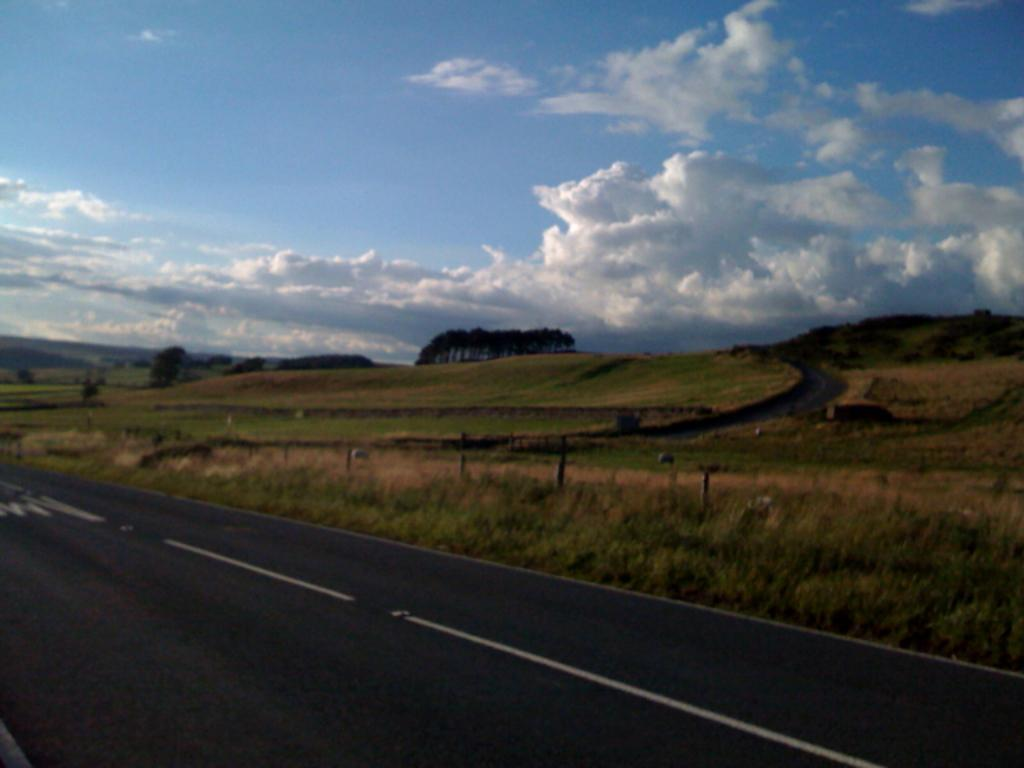What is located at the bottom of the image? There is a road, grass, and plants at the bottom of the image. What type of vegetation can be seen at the bottom of the image? There are plants at the bottom of the image. What can be seen in the background of the image? There are trees and mountains in the background of the image. What is visible at the top of the image? The sky is visible at the top of the image. What type of quartz can be seen in the field in the image? There is no field or quartz present in the image. What does the road need to function properly in the image? The road does not require any specific needs to function properly in the image; it is simply a part of the landscape. 